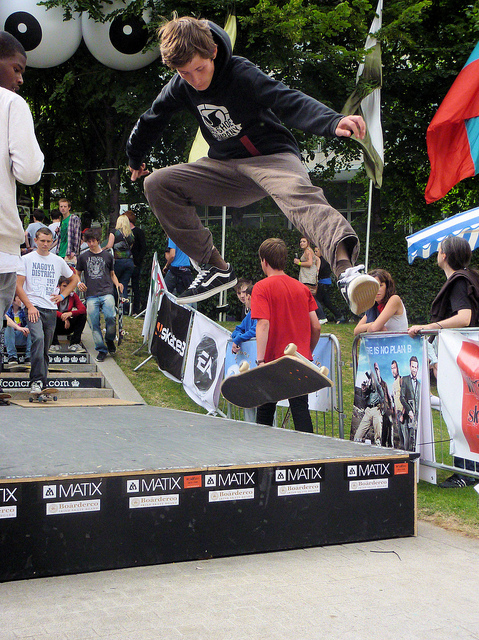Extract all visible text content from this image. MATIX MATIX MATIX MATIX IX NO PLAY DISTRICT CONCR COM EA 